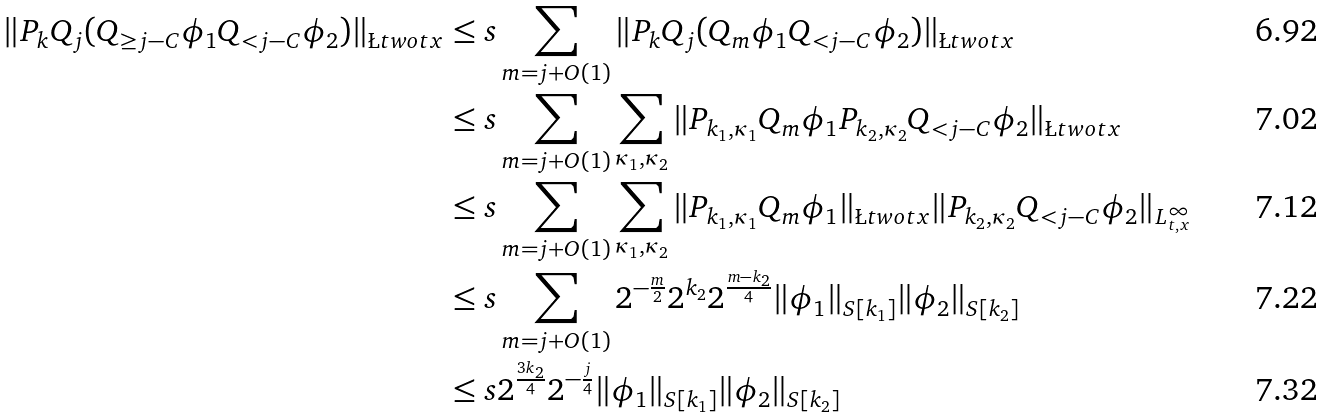Convert formula to latex. <formula><loc_0><loc_0><loc_500><loc_500>\| P _ { k } Q _ { j } ( Q _ { \geq j - C } \phi _ { 1 } Q _ { < j - C } \phi _ { 2 } ) \| _ { \L t w o t x } & \leq s \sum _ { m = j + O ( 1 ) } \| P _ { k } Q _ { j } ( Q _ { m } \phi _ { 1 } Q _ { < j - C } \phi _ { 2 } ) \| _ { \L t w o t x } \\ & \leq s \sum _ { m = j + O ( 1 ) } \sum _ { \kappa _ { 1 } , \kappa _ { 2 } } \| P _ { k _ { 1 } , \kappa _ { 1 } } Q _ { m } \phi _ { 1 } P _ { k _ { 2 } , \kappa _ { 2 } } Q _ { < j - C } \phi _ { 2 } \| _ { \L t w o t x } \\ & \leq s \sum _ { m = j + O ( 1 ) } \sum _ { \kappa _ { 1 } , \kappa _ { 2 } } \| P _ { k _ { 1 } , \kappa _ { 1 } } Q _ { m } \phi _ { 1 } \| _ { \L t w o t x } \| P _ { k _ { 2 } , \kappa _ { 2 } } Q _ { < j - C } \phi _ { 2 } \| _ { L ^ { \infty } _ { t , x } } \\ & \leq s \sum _ { m = j + O ( 1 ) } 2 ^ { - \frac { m } { 2 } } 2 ^ { k _ { 2 } } 2 ^ { \frac { m - k _ { 2 } } { 4 } } \| \phi _ { 1 } \| _ { S [ k _ { 1 } ] } \| \phi _ { 2 } \| _ { S [ k _ { 2 } ] } \\ & \leq s 2 ^ { \frac { 3 k _ { 2 } } { 4 } } 2 ^ { - \frac { j } { 4 } } \| \phi _ { 1 } \| _ { S [ k _ { 1 } ] } \| \phi _ { 2 } \| _ { S [ k _ { 2 } ] }</formula> 